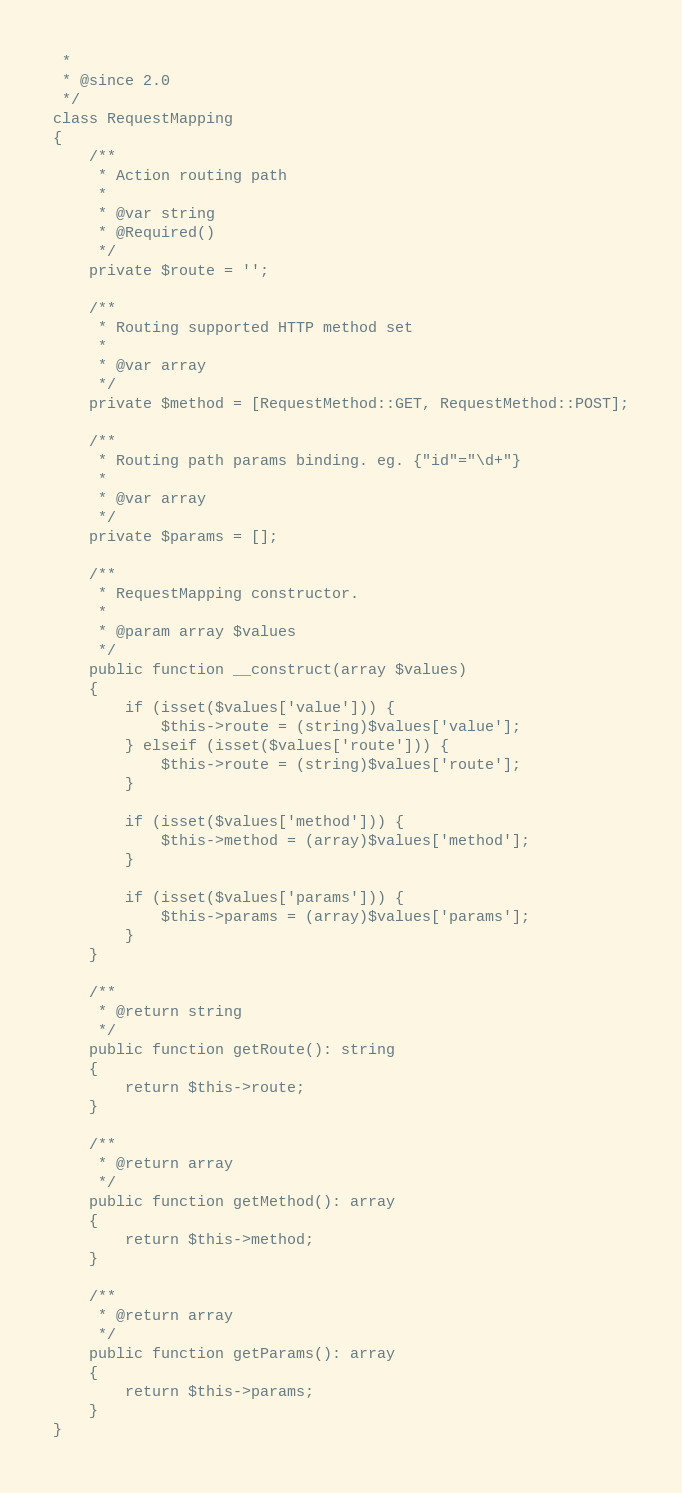<code> <loc_0><loc_0><loc_500><loc_500><_PHP_> *
 * @since 2.0
 */
class RequestMapping
{
    /**
     * Action routing path
     *
     * @var string
     * @Required()
     */
    private $route = '';

    /**
     * Routing supported HTTP method set
     *
     * @var array
     */
    private $method = [RequestMethod::GET, RequestMethod::POST];

    /**
     * Routing path params binding. eg. {"id"="\d+"}
     *
     * @var array
     */
    private $params = [];

    /**
     * RequestMapping constructor.
     *
     * @param array $values
     */
    public function __construct(array $values)
    {
        if (isset($values['value'])) {
            $this->route = (string)$values['value'];
        } elseif (isset($values['route'])) {
            $this->route = (string)$values['route'];
        }

        if (isset($values['method'])) {
            $this->method = (array)$values['method'];
        }

        if (isset($values['params'])) {
            $this->params = (array)$values['params'];
        }
    }

    /**
     * @return string
     */
    public function getRoute(): string
    {
        return $this->route;
    }

    /**
     * @return array
     */
    public function getMethod(): array
    {
        return $this->method;
    }

    /**
     * @return array
     */
    public function getParams(): array
    {
        return $this->params;
    }
}
</code> 